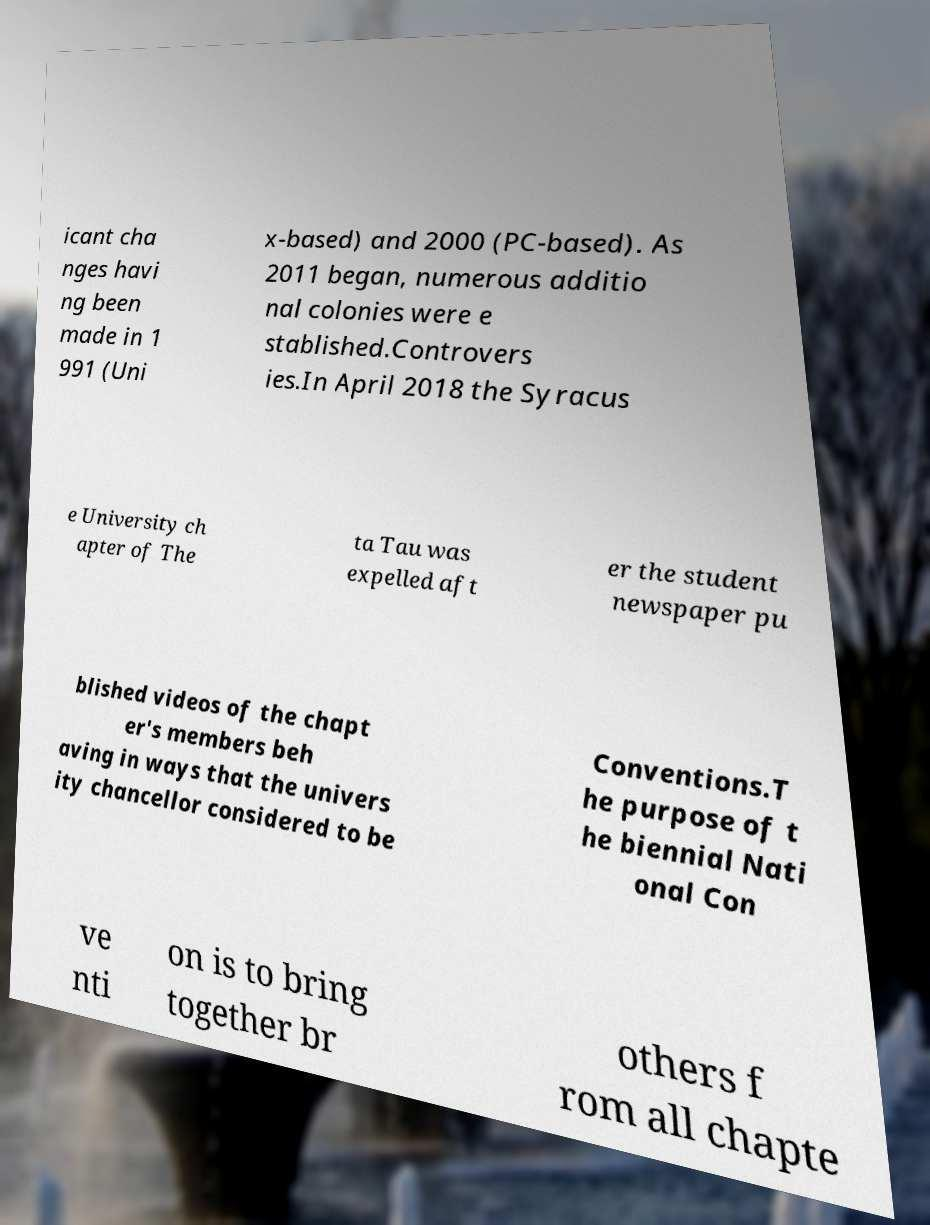I need the written content from this picture converted into text. Can you do that? icant cha nges havi ng been made in 1 991 (Uni x-based) and 2000 (PC-based). As 2011 began, numerous additio nal colonies were e stablished.Controvers ies.In April 2018 the Syracus e University ch apter of The ta Tau was expelled aft er the student newspaper pu blished videos of the chapt er's members beh aving in ways that the univers ity chancellor considered to be Conventions.T he purpose of t he biennial Nati onal Con ve nti on is to bring together br others f rom all chapte 